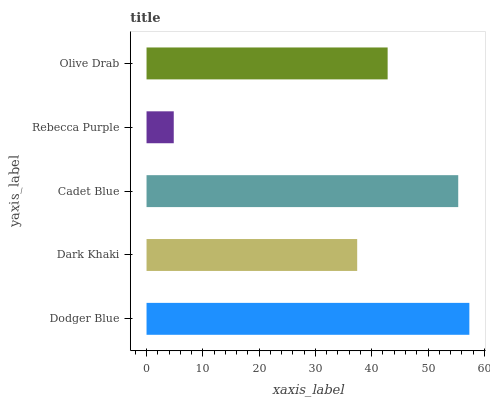Is Rebecca Purple the minimum?
Answer yes or no. Yes. Is Dodger Blue the maximum?
Answer yes or no. Yes. Is Dark Khaki the minimum?
Answer yes or no. No. Is Dark Khaki the maximum?
Answer yes or no. No. Is Dodger Blue greater than Dark Khaki?
Answer yes or no. Yes. Is Dark Khaki less than Dodger Blue?
Answer yes or no. Yes. Is Dark Khaki greater than Dodger Blue?
Answer yes or no. No. Is Dodger Blue less than Dark Khaki?
Answer yes or no. No. Is Olive Drab the high median?
Answer yes or no. Yes. Is Olive Drab the low median?
Answer yes or no. Yes. Is Rebecca Purple the high median?
Answer yes or no. No. Is Rebecca Purple the low median?
Answer yes or no. No. 